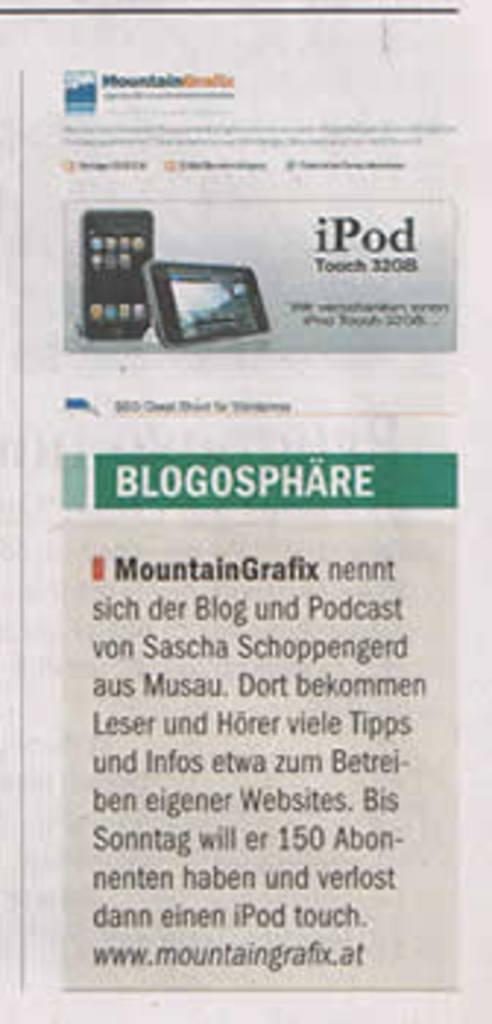<image>
Offer a succinct explanation of the picture presented. A newspaper article about blogs featuring MountainGrafix with a website listed at the bottom. 